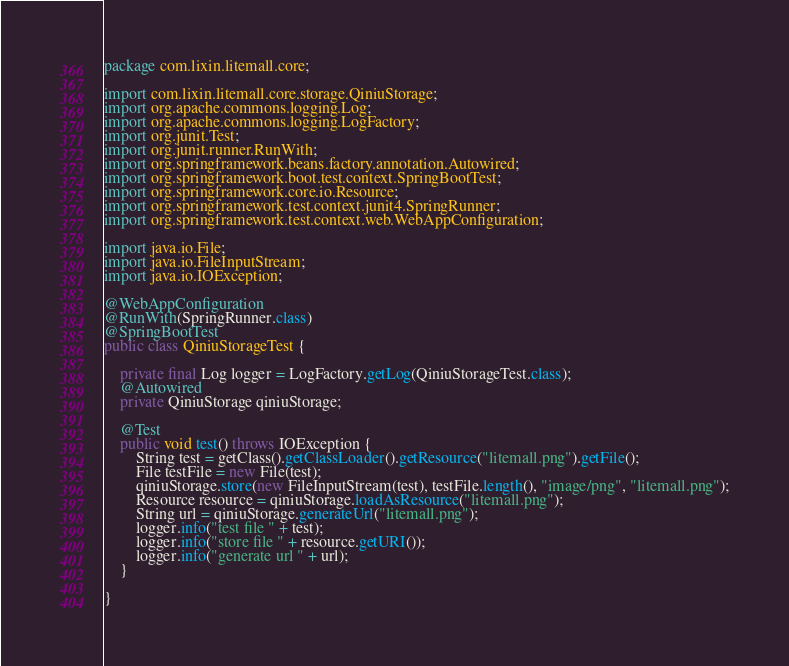<code> <loc_0><loc_0><loc_500><loc_500><_Java_>package com.lixin.litemall.core;

import com.lixin.litemall.core.storage.QiniuStorage;
import org.apache.commons.logging.Log;
import org.apache.commons.logging.LogFactory;
import org.junit.Test;
import org.junit.runner.RunWith;
import org.springframework.beans.factory.annotation.Autowired;
import org.springframework.boot.test.context.SpringBootTest;
import org.springframework.core.io.Resource;
import org.springframework.test.context.junit4.SpringRunner;
import org.springframework.test.context.web.WebAppConfiguration;

import java.io.File;
import java.io.FileInputStream;
import java.io.IOException;

@WebAppConfiguration
@RunWith(SpringRunner.class)
@SpringBootTest
public class QiniuStorageTest {

    private final Log logger = LogFactory.getLog(QiniuStorageTest.class);
    @Autowired
    private QiniuStorage qiniuStorage;

    @Test
    public void test() throws IOException {
        String test = getClass().getClassLoader().getResource("litemall.png").getFile();
        File testFile = new File(test);
        qiniuStorage.store(new FileInputStream(test), testFile.length(), "image/png", "litemall.png");
        Resource resource = qiniuStorage.loadAsResource("litemall.png");
        String url = qiniuStorage.generateUrl("litemall.png");
        logger.info("test file " + test);
        logger.info("store file " + resource.getURI());
        logger.info("generate url " + url);
    }

}
</code> 